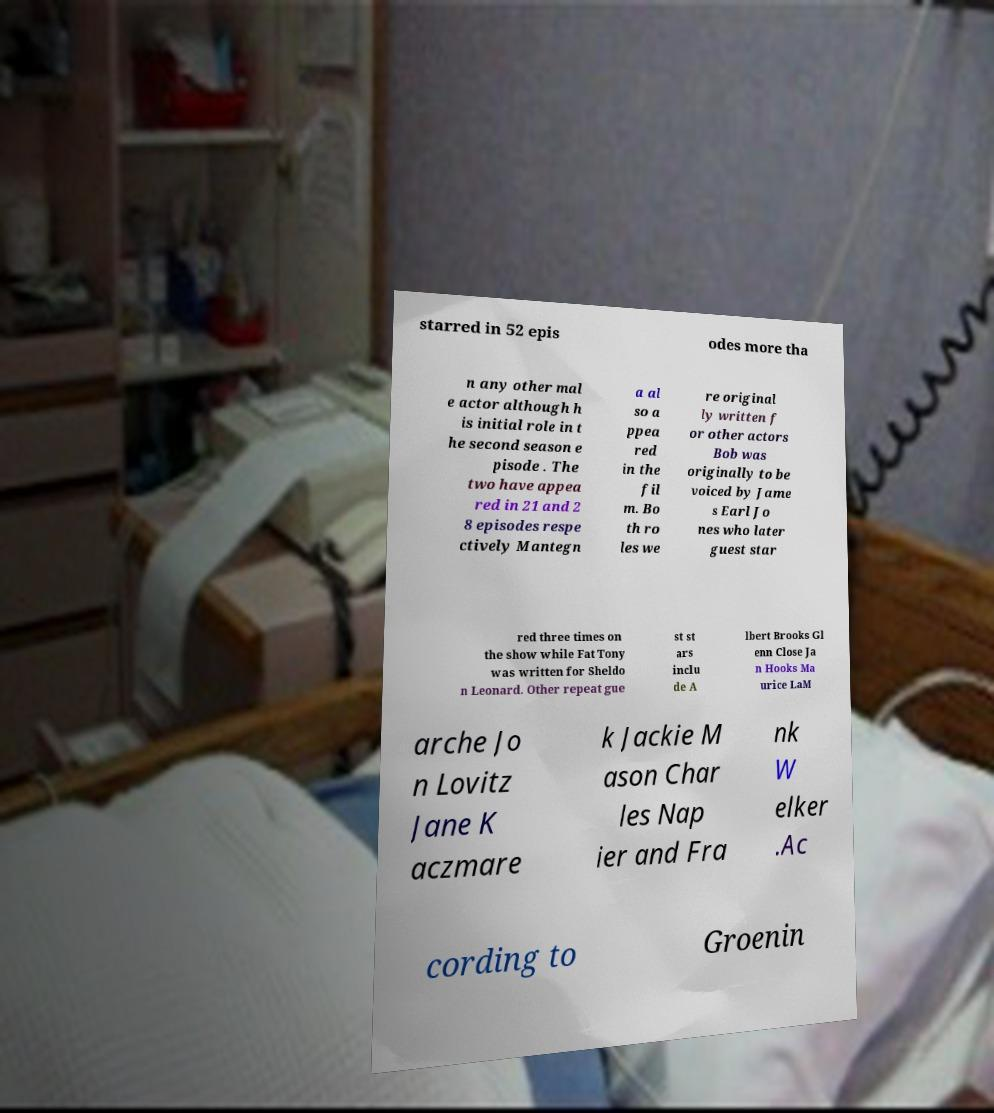Can you read and provide the text displayed in the image?This photo seems to have some interesting text. Can you extract and type it out for me? starred in 52 epis odes more tha n any other mal e actor although h is initial role in t he second season e pisode . The two have appea red in 21 and 2 8 episodes respe ctively Mantegn a al so a ppea red in the fil m. Bo th ro les we re original ly written f or other actors Bob was originally to be voiced by Jame s Earl Jo nes who later guest star red three times on the show while Fat Tony was written for Sheldo n Leonard. Other repeat gue st st ars inclu de A lbert Brooks Gl enn Close Ja n Hooks Ma urice LaM arche Jo n Lovitz Jane K aczmare k Jackie M ason Char les Nap ier and Fra nk W elker .Ac cording to Groenin 